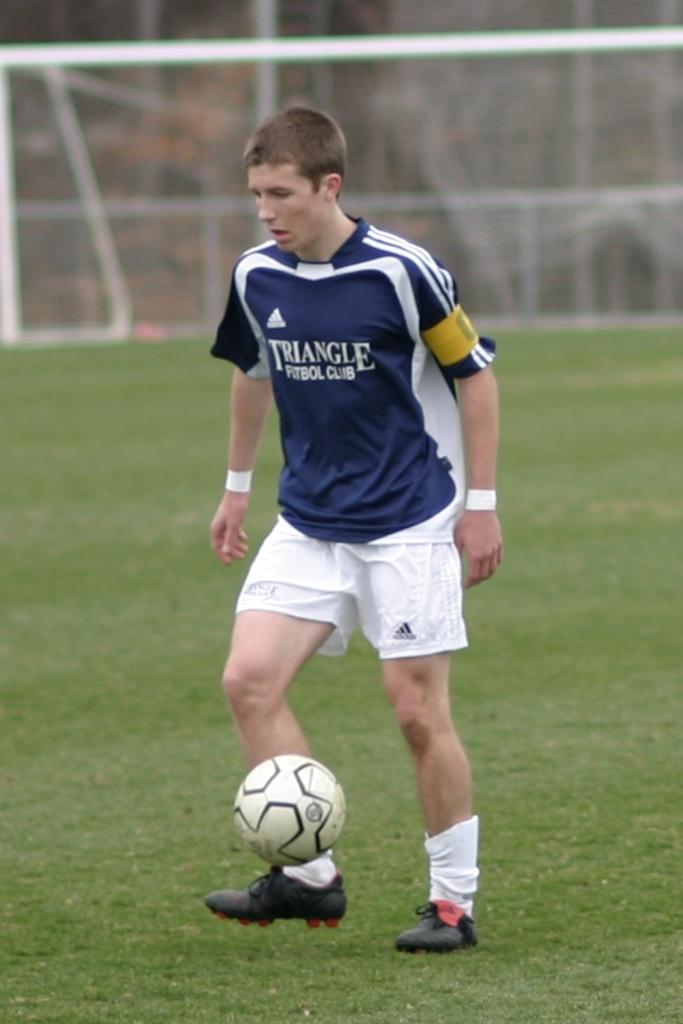<image>
Relay a brief, clear account of the picture shown. Youth soccer player that has a navy jersey on it with white letter Triangle. 